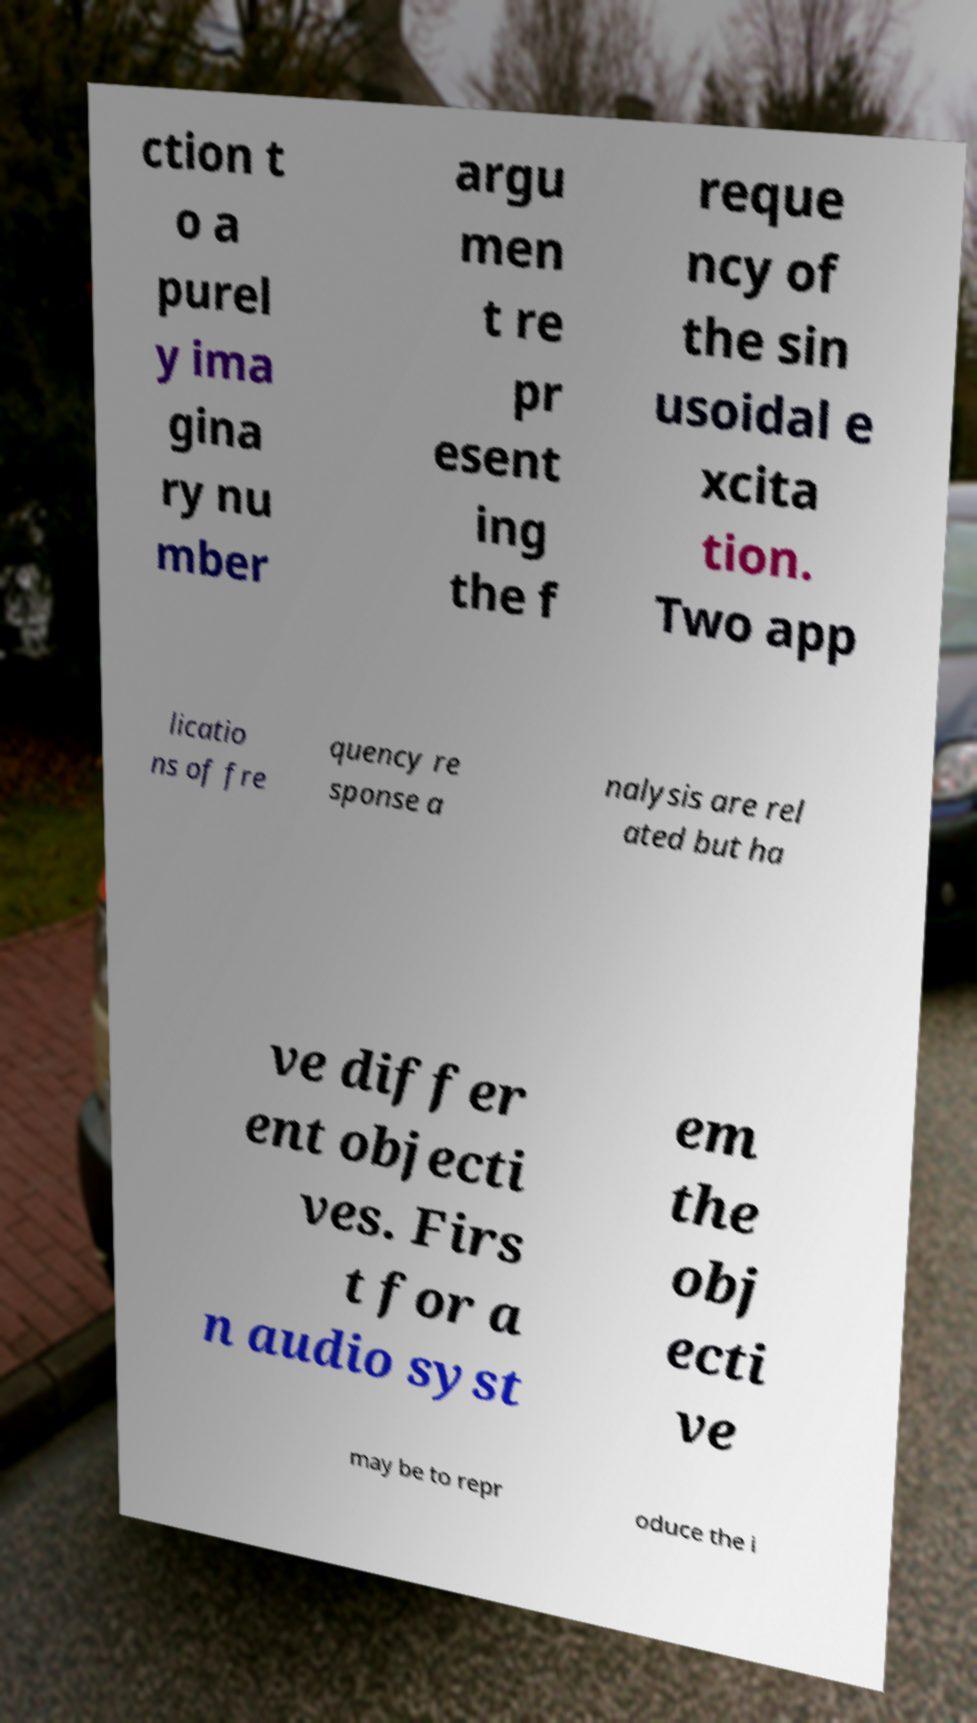Could you extract and type out the text from this image? ction t o a purel y ima gina ry nu mber argu men t re pr esent ing the f reque ncy of the sin usoidal e xcita tion. Two app licatio ns of fre quency re sponse a nalysis are rel ated but ha ve differ ent objecti ves. Firs t for a n audio syst em the obj ecti ve may be to repr oduce the i 